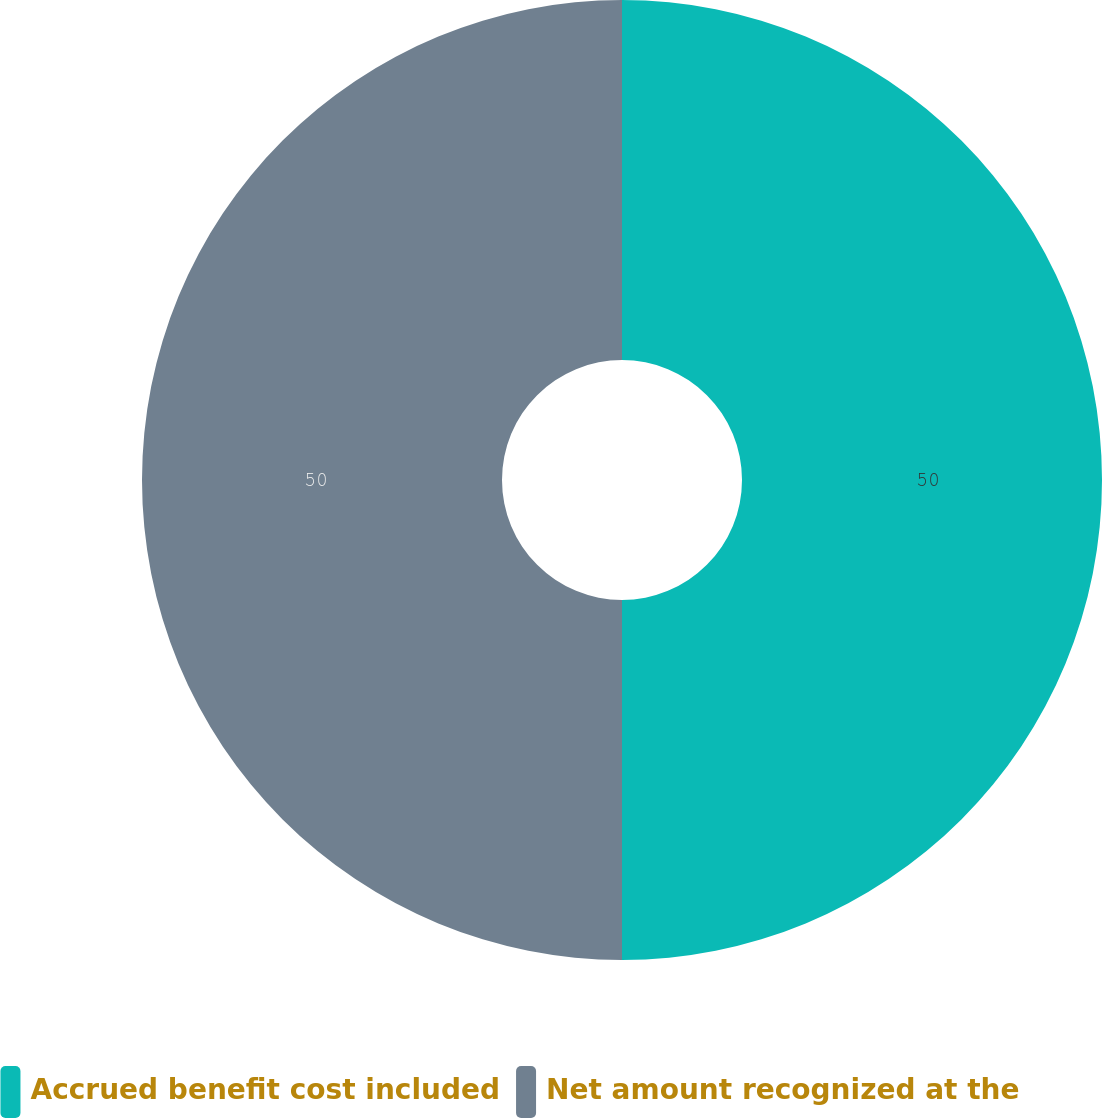Convert chart to OTSL. <chart><loc_0><loc_0><loc_500><loc_500><pie_chart><fcel>Accrued benefit cost included<fcel>Net amount recognized at the<nl><fcel>50.0%<fcel>50.0%<nl></chart> 